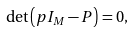Convert formula to latex. <formula><loc_0><loc_0><loc_500><loc_500>\det \left ( p I _ { M } - P \right ) = 0 ,</formula> 